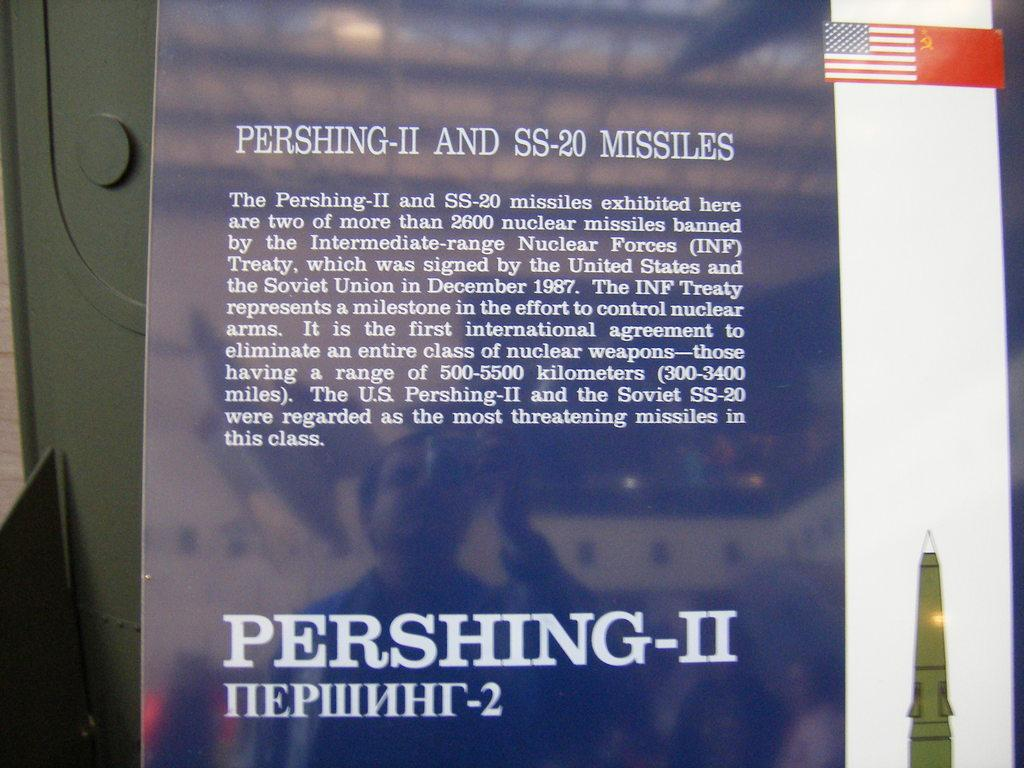Provide a one-sentence caption for the provided image. A blue sign describes Pershing-II and SS-20 missiles. 